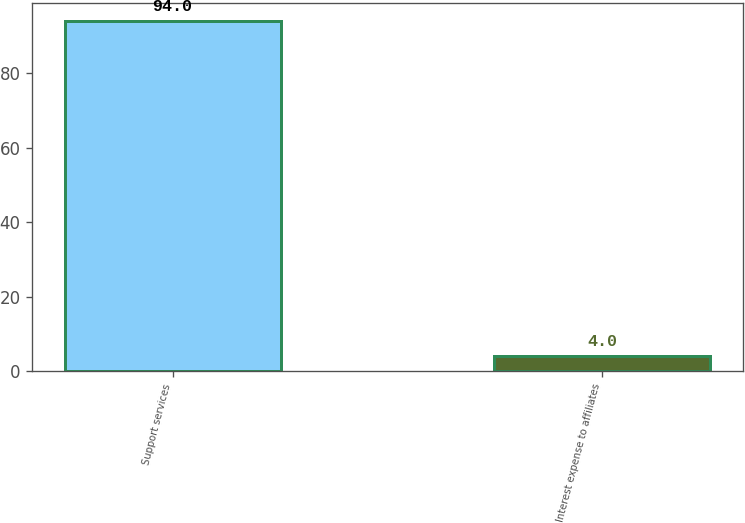Convert chart to OTSL. <chart><loc_0><loc_0><loc_500><loc_500><bar_chart><fcel>Support services<fcel>Interest expense to affiliates<nl><fcel>94<fcel>4<nl></chart> 